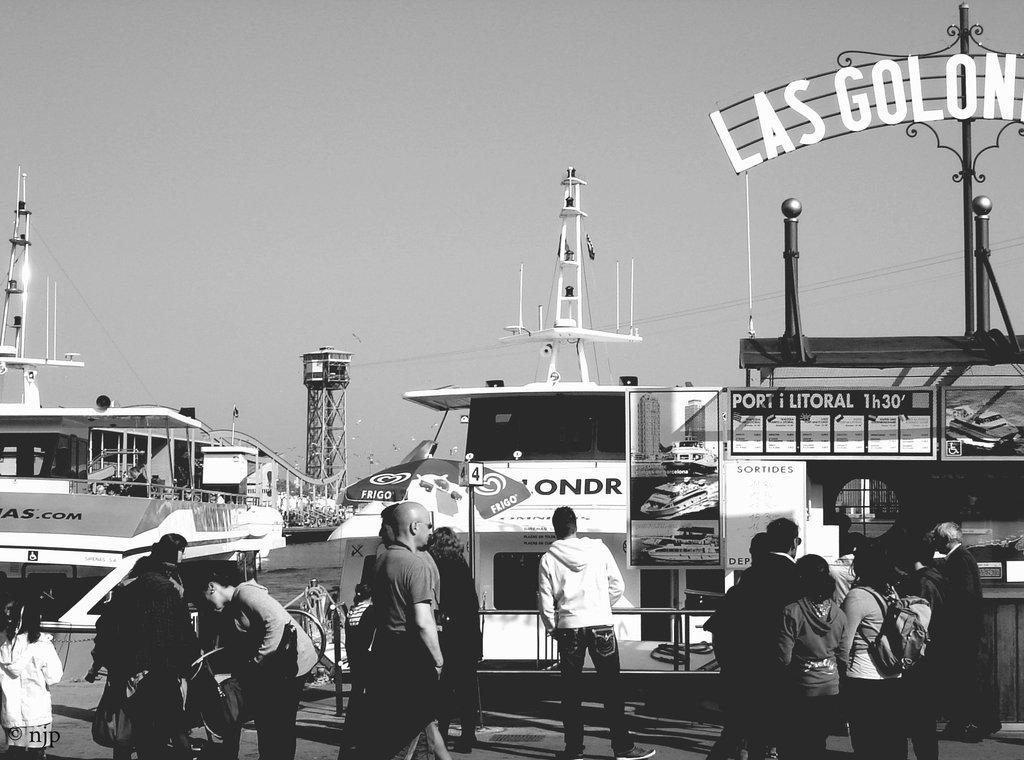In one or two sentences, can you explain what this image depicts? This is a black and white image of group of people standing on the ground. We can also see some boards with pictures and text on them, poles, an outdoor umbrella, the metal frame, some wires and the sky. 